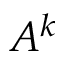Convert formula to latex. <formula><loc_0><loc_0><loc_500><loc_500>A ^ { k }</formula> 